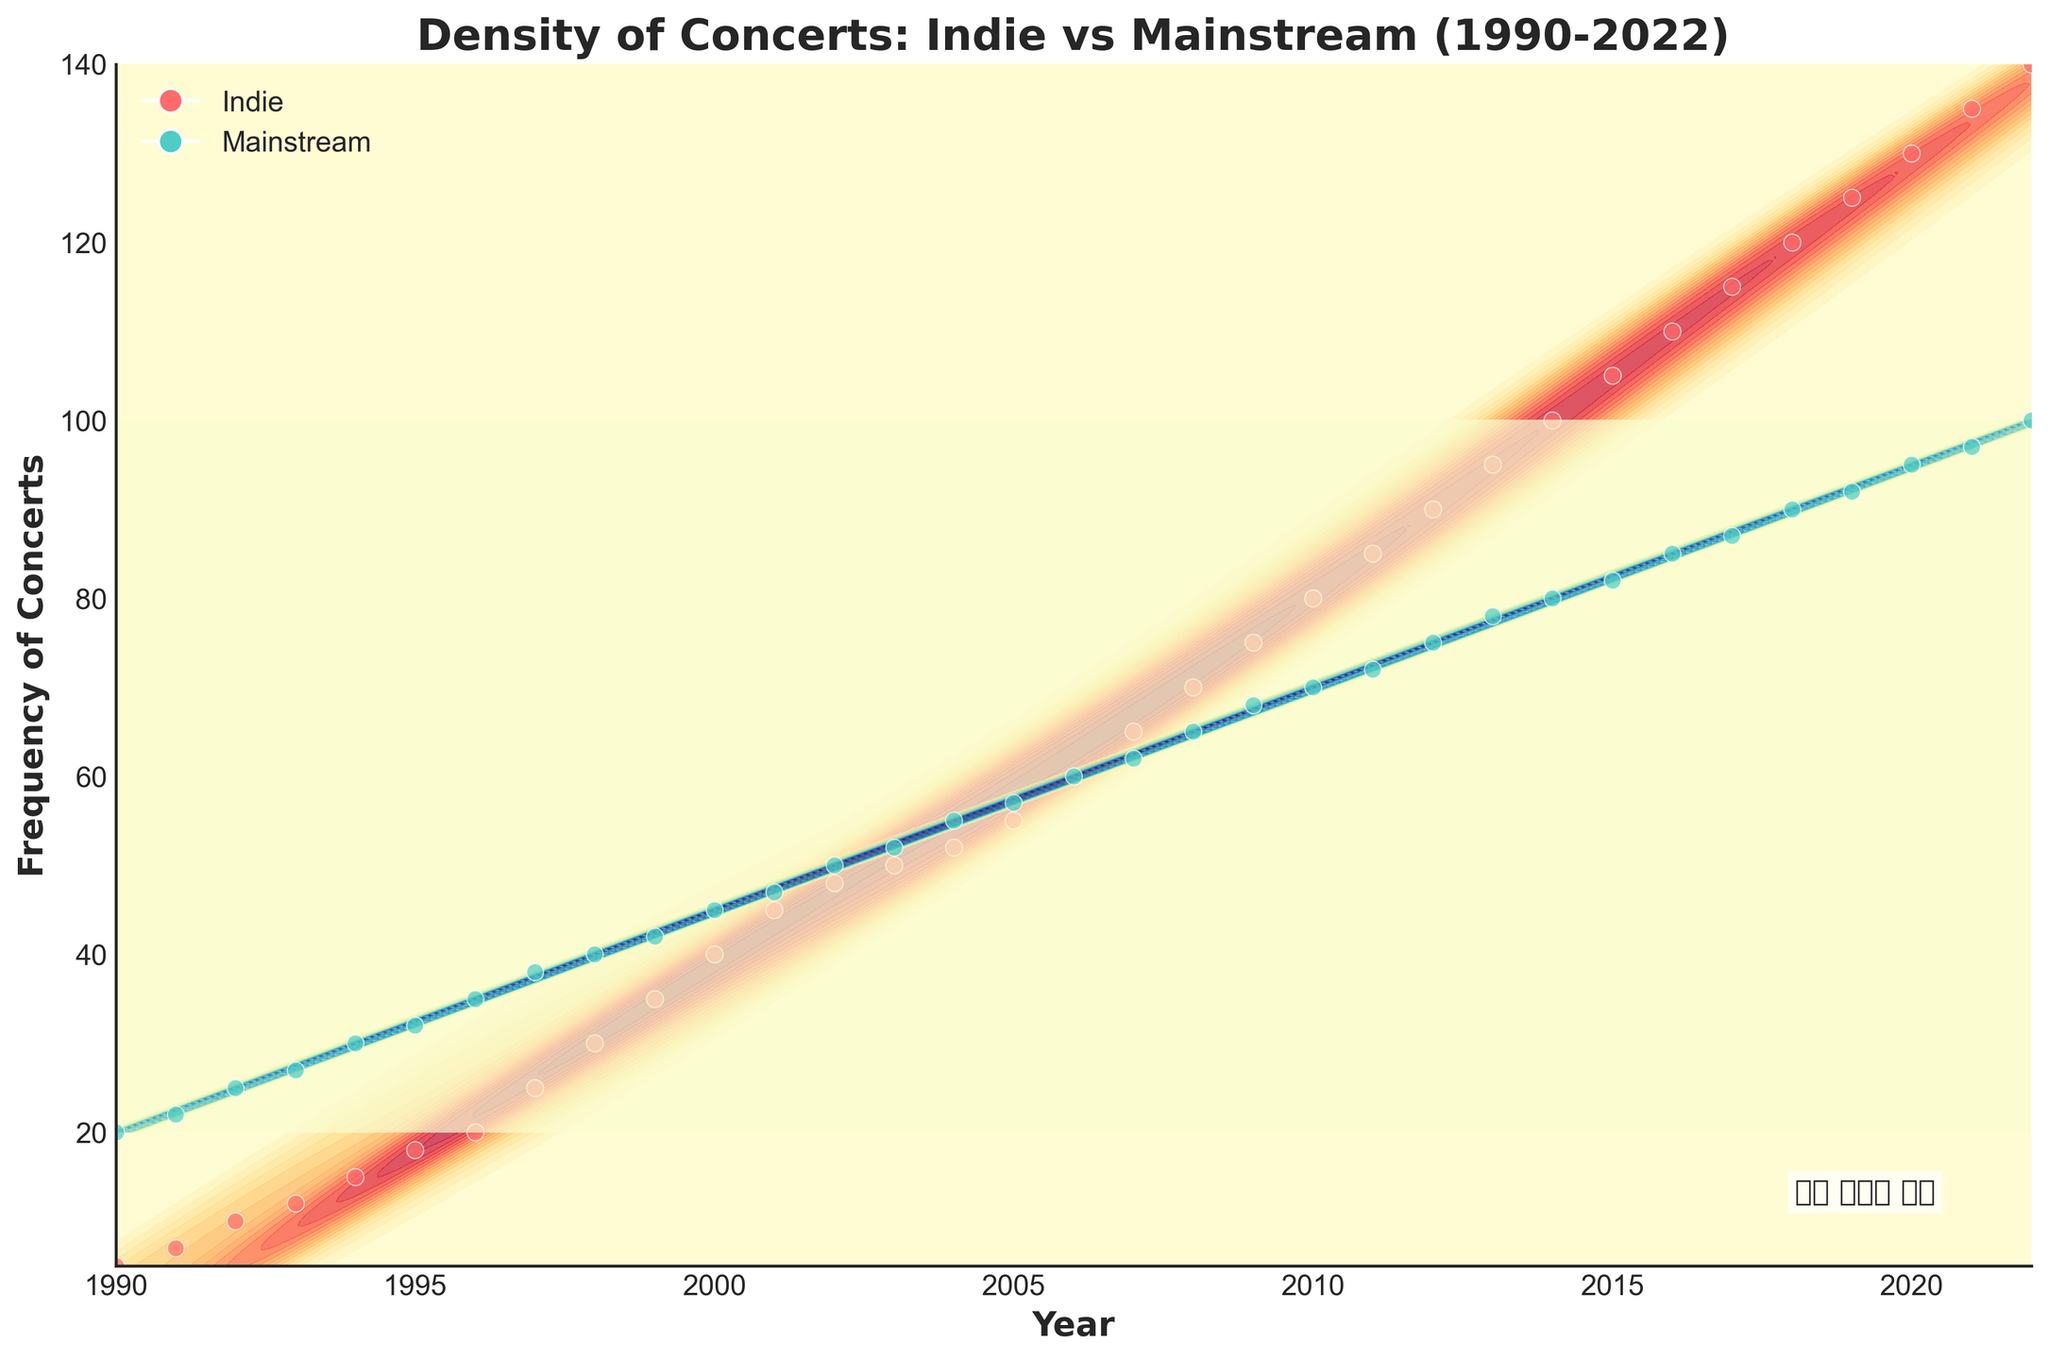What is the title of the figure? The title of the figure is given at the top of the plot. It states the main subject of the plot which is the density of concerts over time for indie and mainstream musicians.
Answer: Density of Concerts: Indie vs Mainstream (1990-2022) What do the x-axis and y-axis represent? The x-axis and y-axis labels describe what is being measured along each axis. In this plot, the x-axis represents the years and the y-axis represents the frequency of concerts.
Answer: x-axis: Year, y-axis: Frequency of Concerts What colors represent Indie and Mainstream musicians in the plot? The legend in the plot indicates which color corresponds to which group. Indie musicians are represented in a reddish color while mainstream musicians are represented in a greenish color.
Answer: Indie: Red, Mainstream: Green Around which year did the frequency of Indie concerts start to surpass Mainstream concerts? By observing the lines representing frequency over the years, we can see that indie concerts start having higher density values compared to mainstream concerts.
Answer: Around 2016 What trend can you observe for both Indie and Mainstream concert frequencies from 1990 to 2022? By looking at the density distributions over the years for both types of musicians, we can describe trends. Both Indie and Mainstream musicians show an increasing trend in concert frequencies, but Indie concerts show a steeper increase from the mid-2000s onward.
Answer: Both frequencies increase, Indie frequencies increase faster around mid-2000s onward How does the variance of concert frequency for Indie musicians compare to that of Mainstream musicians over the years? By looking at the width of the density distributions over the years, if the spread of values (variance) is wider for one group compared to the other.
Answer: Indie has higher variance, wider distribution In which year did Indie musicians' concert frequency reach 100? By tracing the point on the density plot where the Indie line crosses 100 on the y-axis.
Answer: 2014 What significant milestone is highlighted by the annotation "인디 음악의 성장"? The annotation on the bottom corner of the plot usually highlights significant observations in the data. This annotation points out the noticeable growth in Indie music concerts.
Answer: Growth of Indie music In the year 2006, which type of musician had the higher frequency of concerts? By looking closely at the data points for the year 2006 on the plot, comparing the relative position of Indie and Mainstream frequencies.
Answer: Mainstream Which decade showed the steepest increase in concert frequency for Indie musicians? By analyzing the slope or steepness of the density curve representing Indie musician data across decades. The period with the most rapid increase indicates the steepest increase.
Answer: 2010s 